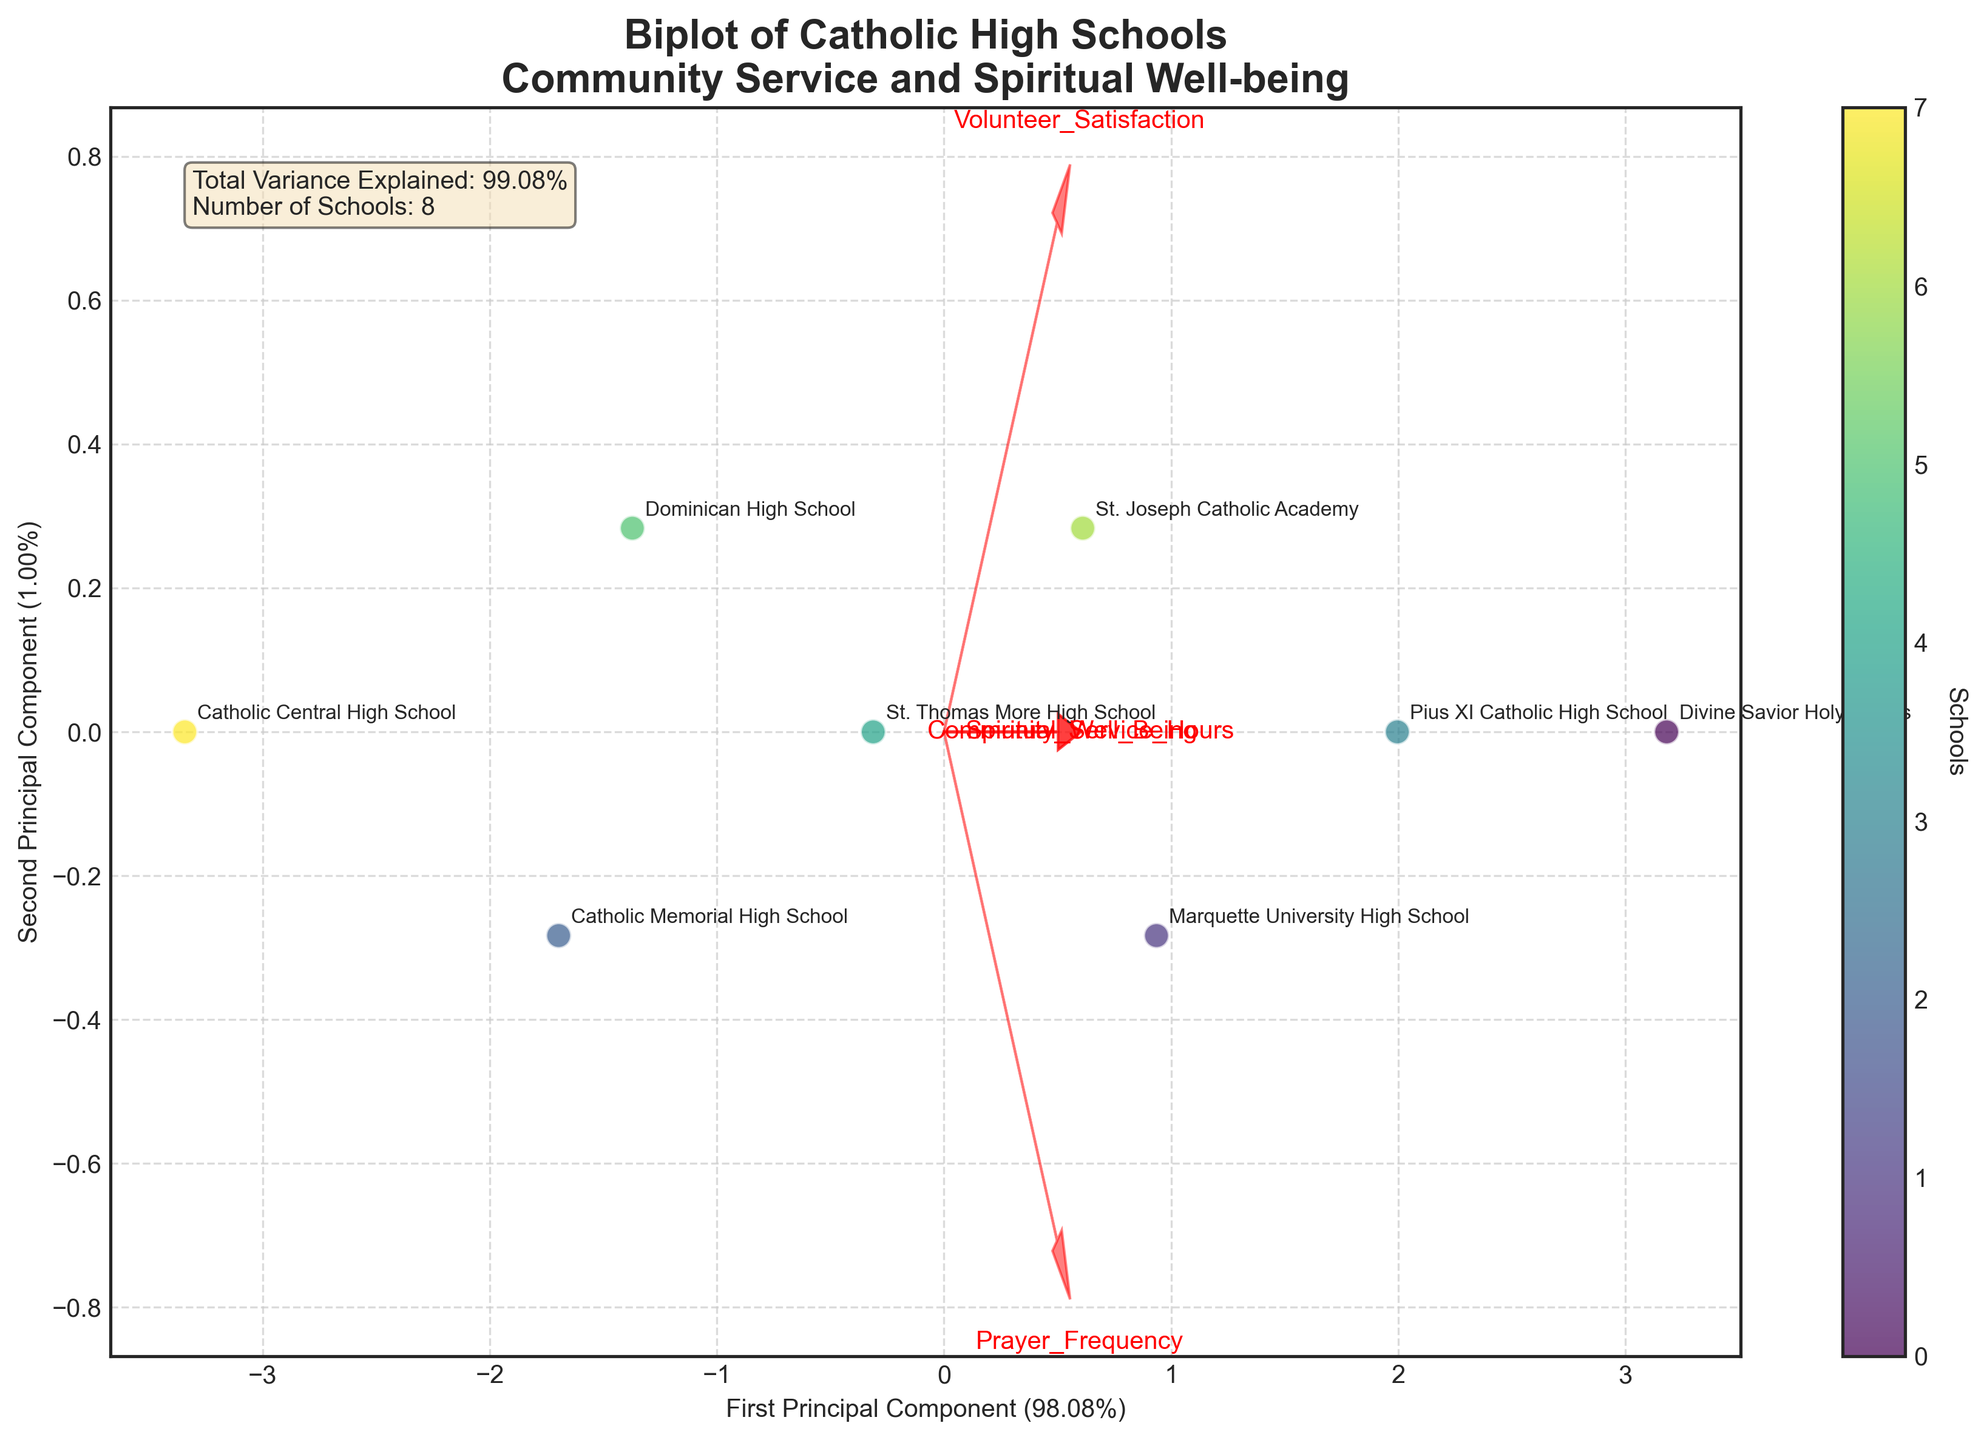What is the main title of the biplot? The main title of the biplot is usually found at the top of the figure, and it summarizes the content of the plot. From the plot, the title is "Biplot of Catholic High Schools\nCommunity Service and Spiritual Well-being".
Answer: Biplot of Catholic High Schools\nCommunity Service and Spiritual Well-being How many schools are represented in the biplot? You can count the number of distinct points or annotations in the plot to determine the number of schools. According to the plot, there are 8 distinct schools.
Answer: 8 Which school has the highest principal component score on the x-axis? To answer this, look at the points labeled with the school names and find the one furthest to the right on the x-axis. The school located the farthest right is "Divine Savior Holy Angels".
Answer: Divine Savior Holy Angels Which feature vector has the longest arrow in the biplot? The feature vector with the longest arrow indicates the feature with the highest importance in the principal components. By observing the plot, "Community_Service_Hours" seems to have the longest arrow.
Answer: Community_Service_Hours How much variance is explained by the first principal component? This percentage is usually stated near the x-axis label. From the biplot, the first principal component explains 50.00% of the variance.
Answer: 50.00% Which school has a higher score on the second principal component, Pius XI Catholic High School or St. Thomas More High School? To find out, compare the positions of these two schools on the y-axis, which represents the second principal component. Pius XI Catholic High School is higher on the y-axis compared to St. Thomas More High School.
Answer: Pius XI Catholic High School Compare the Volunteer Satisfaction scores of "Catholic Central High School" and "Marquette University High School". Volunteer Satisfaction scores can be compared by how close the schools are to the Volunteer Satisfaction vector. Marquette University High School is closer to the Volunteer Satisfaction vector, indicating higher satisfaction.
Answer: Marquette University High School Which feature is most closely aligned with the first principal component? The feature most aligned with the first principal component is the one whose arrow is closest to the direction of the first principal component (x-axis). "Community_Service_Hours" is most aligned with the first principal component.
Answer: Community_Service_Hours What relation can be inferred between spiritual well-being and mass attendance? Compare the directions of the arrows representing "Spiritual_Well_Being" and "Mass_Attendance". Since both arrows point roughly in the same direction, this indicates a positive correlation.
Answer: Positive correlation Which school has the lowest Community Service Hours? To find this school, check the schools’ positions relative to the "Community_Service_Hours" vector. "Catholic Central High School" is the farthest in the opposite direction of this vector.
Answer: Catholic Central High School 